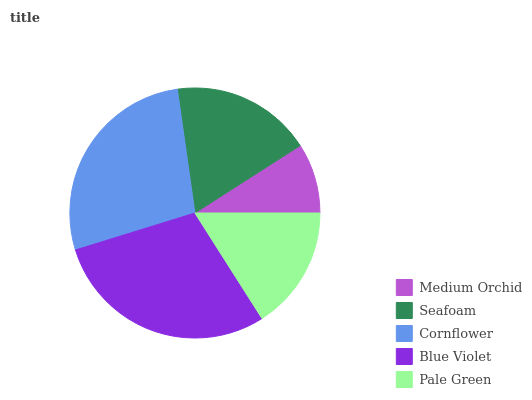Is Medium Orchid the minimum?
Answer yes or no. Yes. Is Blue Violet the maximum?
Answer yes or no. Yes. Is Seafoam the minimum?
Answer yes or no. No. Is Seafoam the maximum?
Answer yes or no. No. Is Seafoam greater than Medium Orchid?
Answer yes or no. Yes. Is Medium Orchid less than Seafoam?
Answer yes or no. Yes. Is Medium Orchid greater than Seafoam?
Answer yes or no. No. Is Seafoam less than Medium Orchid?
Answer yes or no. No. Is Seafoam the high median?
Answer yes or no. Yes. Is Seafoam the low median?
Answer yes or no. Yes. Is Blue Violet the high median?
Answer yes or no. No. Is Pale Green the low median?
Answer yes or no. No. 